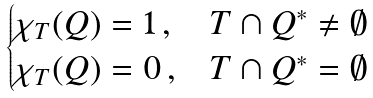<formula> <loc_0><loc_0><loc_500><loc_500>\begin{cases} \chi _ { T } ( Q ) = 1 \, , & T \cap Q ^ { * } \ne \emptyset \\ \chi _ { T } ( Q ) = 0 \, , & T \cap Q ^ { * } = \emptyset \end{cases}</formula> 